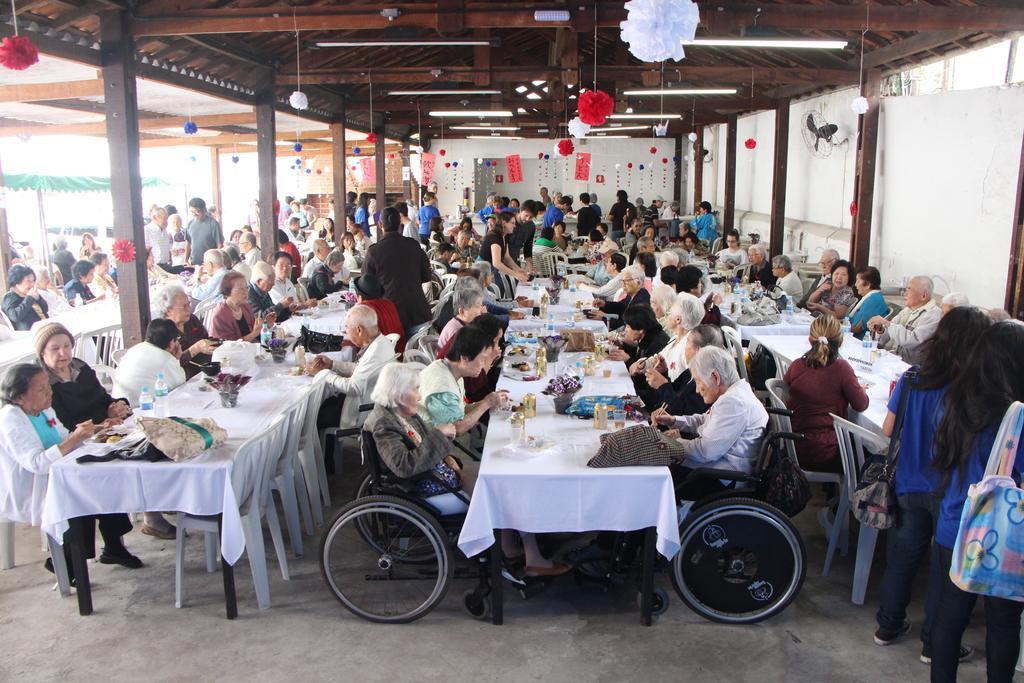Describe this image in one or two sentences. In the picture we can see a wooden shed with some poles to it and under it we can see three rows of tables and chairs and people sitting and having their meals and to the ceiling we can see lights and some decorated flowers which are red and white in color and outside the shed we can see some people are walking. 